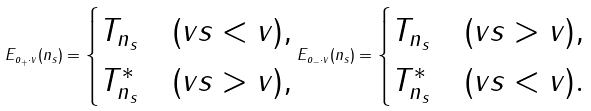<formula> <loc_0><loc_0><loc_500><loc_500>E _ { o _ { + } \cdot v } ( n _ { s } ) = \begin{cases} T _ { n _ { s } } & ( v s < v ) , \\ T _ { n _ { s } } ^ { * } & ( v s > v ) , \end{cases} E _ { o _ { - } \cdot v } ( n _ { s } ) = \begin{cases} T _ { n _ { s } } & ( v s > v ) , \\ T _ { n _ { s } } ^ { * } & ( v s < v ) . \end{cases}</formula> 